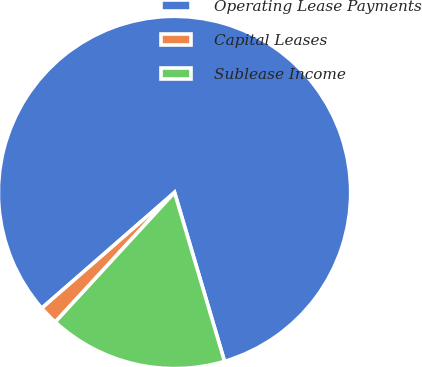<chart> <loc_0><loc_0><loc_500><loc_500><pie_chart><fcel>Operating Lease Payments<fcel>Capital Leases<fcel>Sublease Income<nl><fcel>81.83%<fcel>1.75%<fcel>16.42%<nl></chart> 